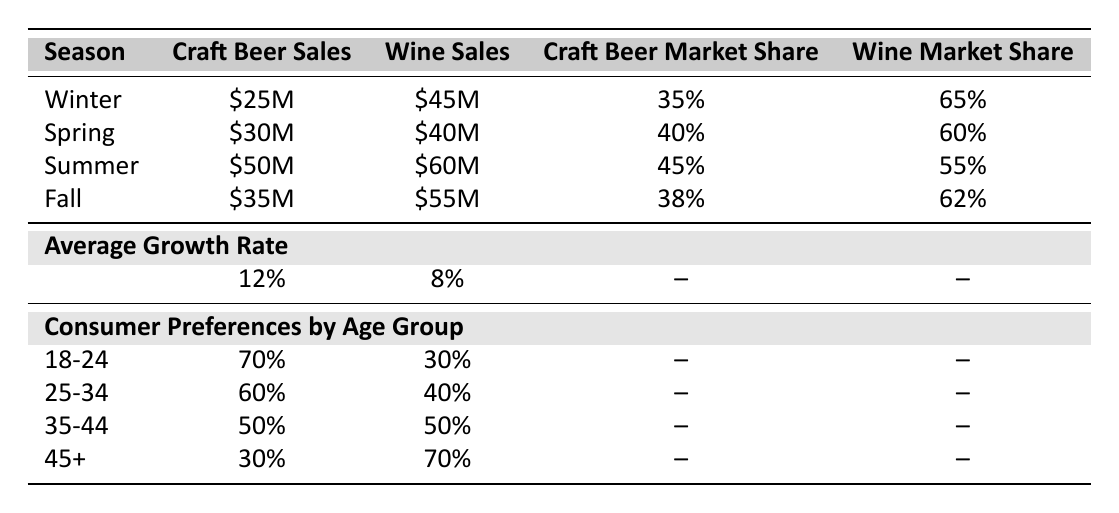What season had the highest craft beer sales? By inspecting the table, we look at the "Craft Beer Sales" column. The sales were 25 million in Winter, 30 million in Spring, 50 million in Summer, and 35 million in Fall. The highest value is 50 million in Summer.
Answer: Summer What was the wine sales figure in Fall? From the table, we look at the "Wine Sales" column specifically for the Fall season, which shows a sales figure of 55 million.
Answer: 55 million Which season saw the highest market share for craft beer? We review the "Craft Beer Market Share" column. The values are 35% in Winter, 40% in Spring, 45% in Summer, and 38% in Fall. The highest market share is 45% in Summer.
Answer: Summer What is the difference in average growth rates between craft beer and wine? The average growth rate for craft beer is 12% and for wine is 8%. To find the difference, subtract the wine growth rate from the craft beer growth rate: 12% - 8% = 4%.
Answer: 4% Is it true that craft beer sales were lower than wine sales in Winter? Looking at the sales figures, craft beer sales were 25 million and wine sales were 45 million. Since 25 million is lower than 45 million, this statement is true.
Answer: Yes During which season did wine sales drop below 60 million? Reviewing the "Wine Sales" figures from the table, we have 65 million in Winter, 60 million in Spring, 55 million in Fall, and 60 million in Summer. Wine sales were below 60 million in Fall only.
Answer: Fall In which age group is the craft beer preference the highest? Referring to the "Consumer Preferences by Age Group" section, the "craft_beer_preference" figures are 70% for 18-24, 60% for 25-34, 50% for 35-44, and 30% for 45+. The highest preference is 70% in the 18-24 age group.
Answer: 18-24 What is the total craft beer and wine sales for Spring? The sales for Spring are 30 million for craft beer and 40 million for wine. To find the total, we add these two values: 30 million + 40 million = 70 million.
Answer: 70 million Which season had the lowest craft beer market share? Checking the "Craft Beer Market Share" column, the values are 35% in Winter, 40% in Spring, 45% in Summer, and 38% in Fall. The lowest value is 35% in Winter.
Answer: Winter 